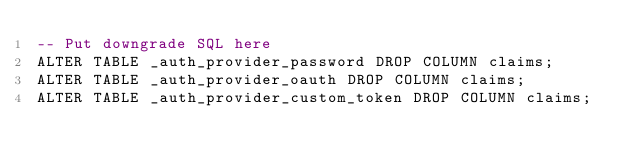Convert code to text. <code><loc_0><loc_0><loc_500><loc_500><_SQL_>-- Put downgrade SQL here
ALTER TABLE _auth_provider_password DROP COLUMN claims;
ALTER TABLE _auth_provider_oauth DROP COLUMN claims;
ALTER TABLE _auth_provider_custom_token DROP COLUMN claims;
</code> 